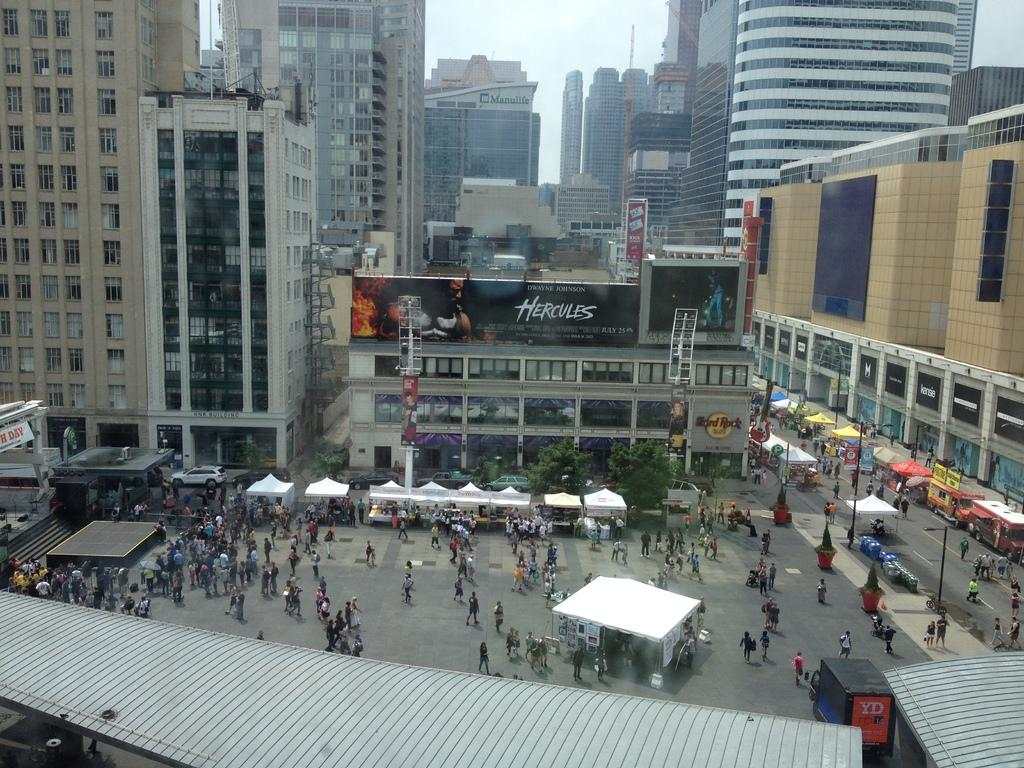What structures are located in the center of the image? There are buildings in the center of the image. What type of temporary shelters can be seen at the bottom of the image? There are tents at the bottom of the image. What type of vegetation is present at the bottom of the image? Trees are present at the bottom of the image. What type of transportation is visible at the bottom of the image? Cars and vehicles are visible at the bottom of the image. What are the people in the image doing? People are walking in the image. What type of small storage buildings are present in the image? There are sheds in the image. What type of powder is being used to develop the buildings in the image? There is no mention of any powder or development process in the image; it simply shows buildings, tents, trees, cars, vehicles, and people walking. Can you tell me how many zippers are visible on the tents in the image? There is no mention of any zippers on the tents in the image; it only shows that there are tents present. 